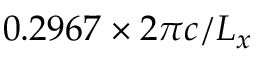<formula> <loc_0><loc_0><loc_500><loc_500>0 . 2 9 6 7 \times 2 \pi c / L _ { x }</formula> 